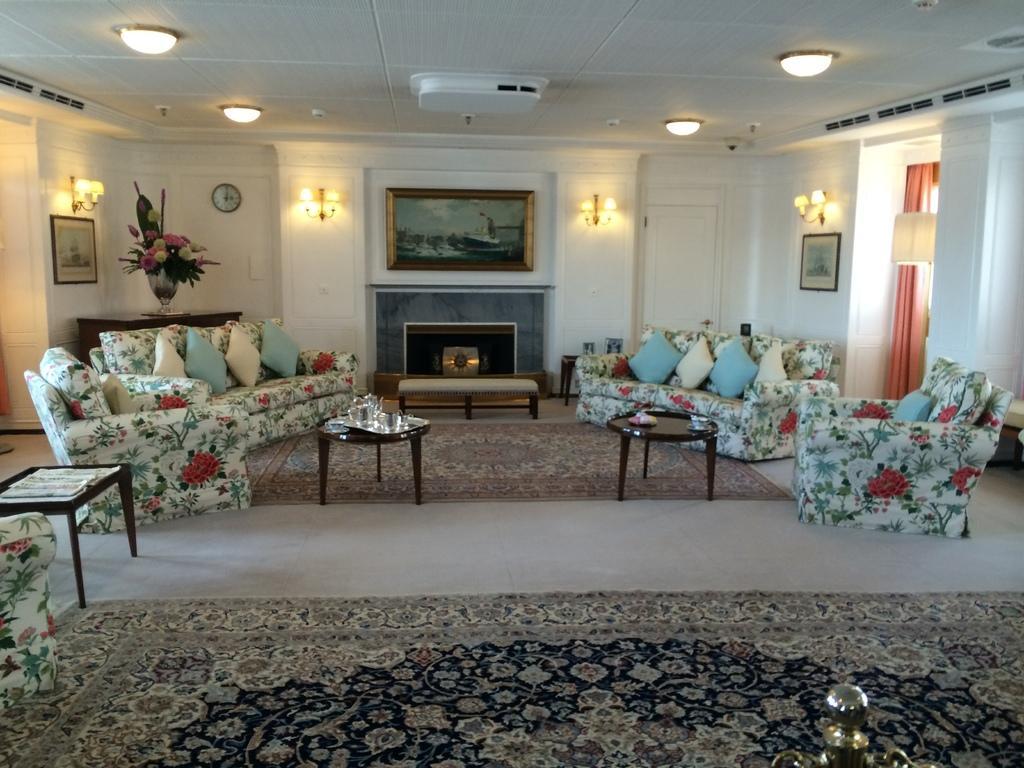Describe this image in one or two sentences. there is a living room,in the living room we can see sofa,table,different items present on the table,wall clocks,lamps,frames and flower vase along with the curtains. 